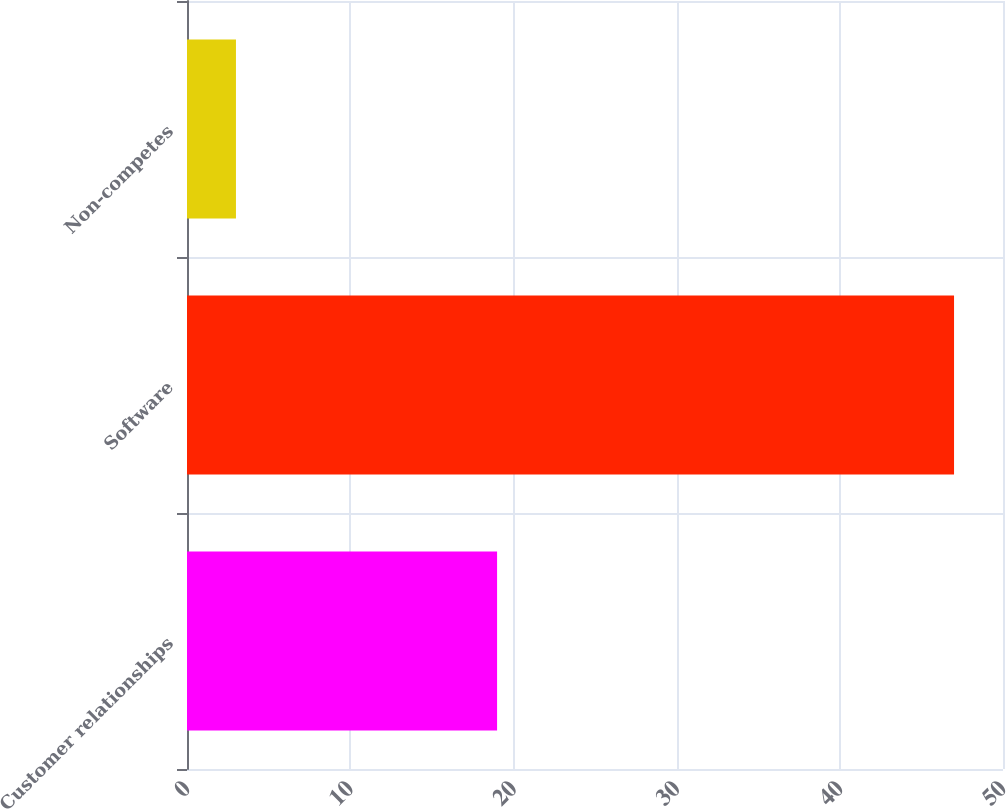<chart> <loc_0><loc_0><loc_500><loc_500><bar_chart><fcel>Customer relationships<fcel>Software<fcel>Non-competes<nl><fcel>19<fcel>47<fcel>3<nl></chart> 